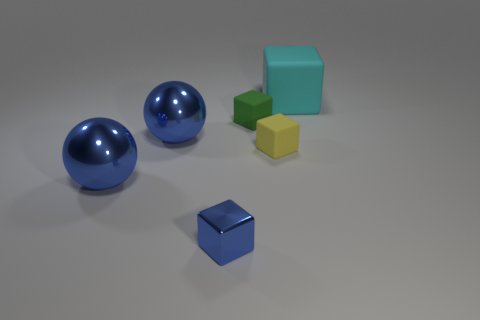Subtract 1 blocks. How many blocks are left? 3 Add 1 tiny yellow metallic spheres. How many objects exist? 7 Subtract all spheres. How many objects are left? 4 Subtract all tiny shiny cubes. Subtract all blue things. How many objects are left? 2 Add 4 small blue things. How many small blue things are left? 5 Add 2 tiny metallic objects. How many tiny metallic objects exist? 3 Subtract 0 brown blocks. How many objects are left? 6 